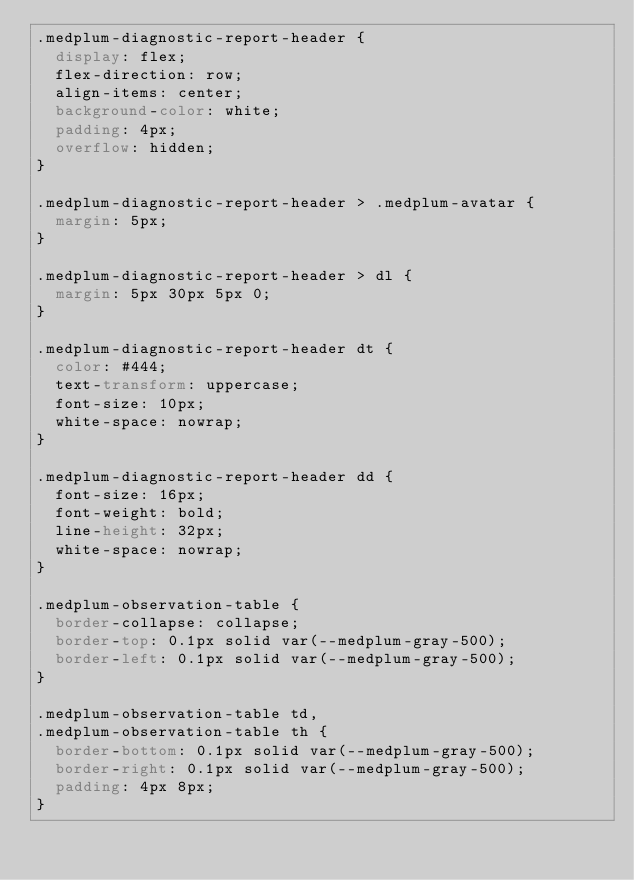<code> <loc_0><loc_0><loc_500><loc_500><_CSS_>.medplum-diagnostic-report-header {
  display: flex;
  flex-direction: row;
  align-items: center;
  background-color: white;
  padding: 4px;
  overflow: hidden;
}

.medplum-diagnostic-report-header > .medplum-avatar {
  margin: 5px;
}

.medplum-diagnostic-report-header > dl {
  margin: 5px 30px 5px 0;
}

.medplum-diagnostic-report-header dt {
  color: #444;
  text-transform: uppercase;
  font-size: 10px;
  white-space: nowrap;
}

.medplum-diagnostic-report-header dd {
  font-size: 16px;
  font-weight: bold;
  line-height: 32px;
  white-space: nowrap;
}

.medplum-observation-table {
  border-collapse: collapse;
  border-top: 0.1px solid var(--medplum-gray-500);
  border-left: 0.1px solid var(--medplum-gray-500);
}

.medplum-observation-table td,
.medplum-observation-table th {
  border-bottom: 0.1px solid var(--medplum-gray-500);
  border-right: 0.1px solid var(--medplum-gray-500);
  padding: 4px 8px;
}
</code> 